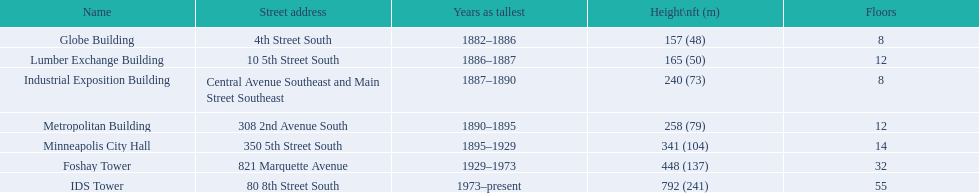Parse the table in full. {'header': ['Name', 'Street address', 'Years as tallest', 'Height\\nft (m)', 'Floors'], 'rows': [['Globe Building', '4th Street South', '1882–1886', '157 (48)', '8'], ['Lumber Exchange Building', '10 5th Street South', '1886–1887', '165 (50)', '12'], ['Industrial Exposition Building', 'Central Avenue Southeast and Main Street Southeast', '1887–1890', '240 (73)', '8'], ['Metropolitan Building', '308 2nd Avenue South', '1890–1895', '258 (79)', '12'], ['Minneapolis City Hall', '350 5th Street South', '1895–1929', '341 (104)', '14'], ['Foshay Tower', '821 Marquette Avenue', '1929–1973', '448 (137)', '32'], ['IDS Tower', '80 8th Street South', '1973–present', '792 (241)', '55']]} Which constructions share the same floor count as another construction? Globe Building, Lumber Exchange Building, Industrial Exposition Building, Metropolitan Building. Out of those, which one is equal to the lumber exchange building? Metropolitan Building. Can you provide the heights of the buildings? 157 (48), 165 (50), 240 (73), 258 (79), 341 (104), 448 (137), 792 (241). Also, identify the building that is 240 ft in height.? Industrial Exposition Building. 